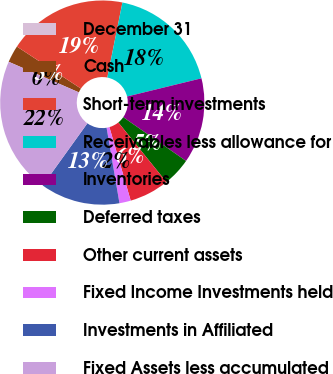<chart> <loc_0><loc_0><loc_500><loc_500><pie_chart><fcel>December 31<fcel>Cash<fcel>Short-term investments<fcel>Receivables less allowance for<fcel>Inventories<fcel>Deferred taxes<fcel>Other current assets<fcel>Fixed Income Investments held<fcel>Investments in Affiliated<fcel>Fixed Assets less accumulated<nl><fcel>0.0%<fcel>2.7%<fcel>18.92%<fcel>18.02%<fcel>13.51%<fcel>4.51%<fcel>6.31%<fcel>1.8%<fcel>12.61%<fcel>21.62%<nl></chart> 